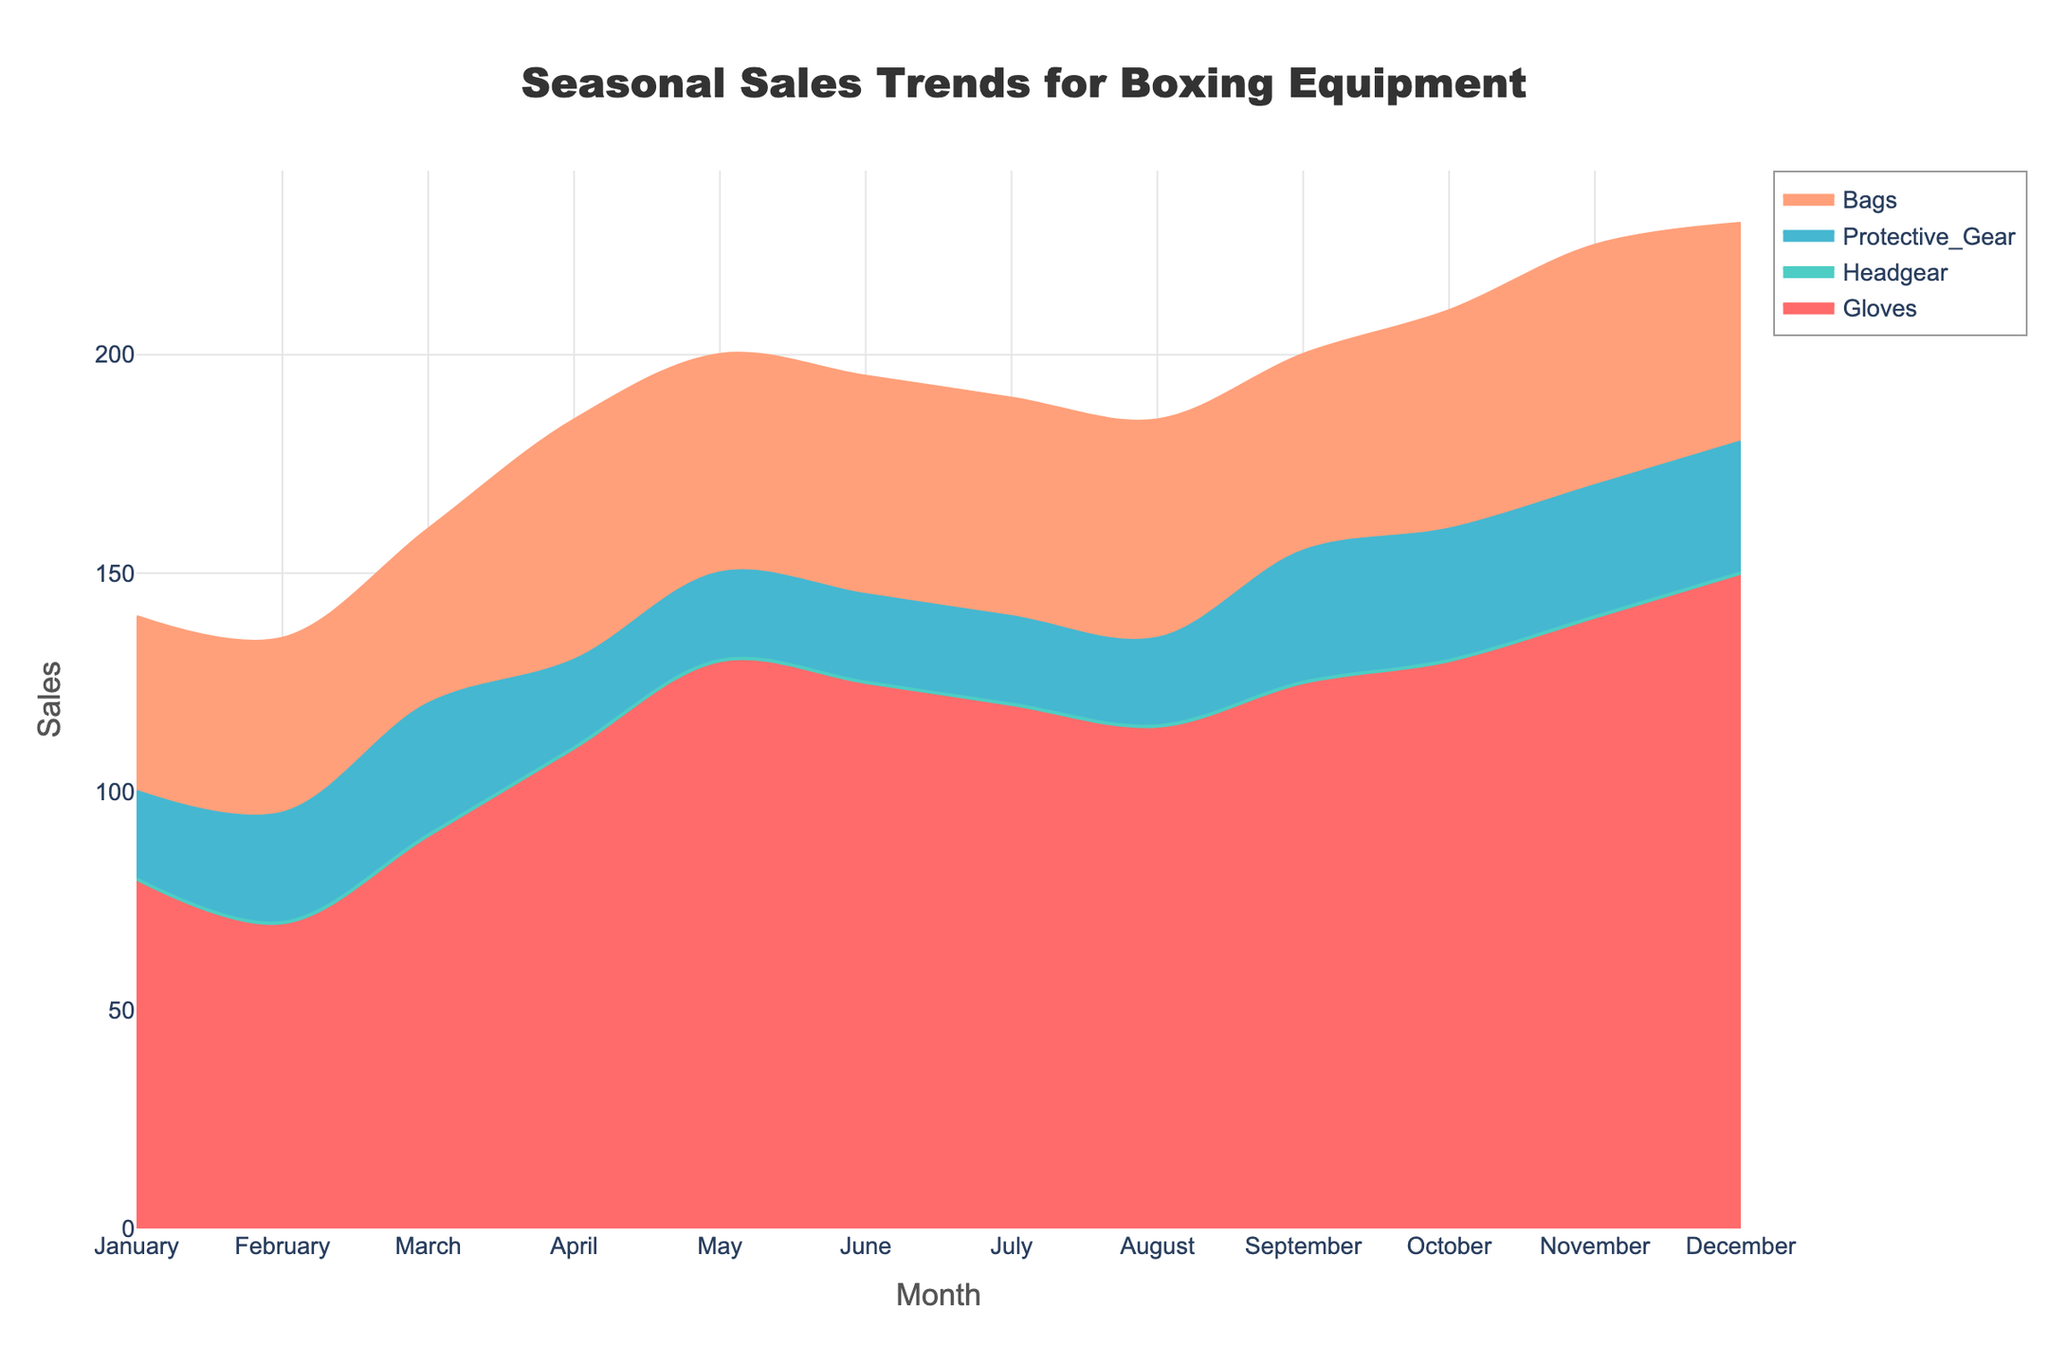What is the title of the plot? The title is located at the top of the figure. It describes the subject of the chart.
Answer: Seasonal Sales Trends for Boxing Equipment Which month has the highest sales for Gloves? To find the month with the highest sales for Gloves, we examine the 'Gloves' area on the chart and identify the peak value over the x-axis (months).
Answer: December What is the total sales for Protective Gear in the first quarter (January to March)? Sum the sales values for January, February, and March for Protective Gear: 100 + 95 + 120 = 315.
Answer: 315 How does the sales trend for Bags change from June to August? Examine the area representing Bags from June to August, noting the rise or fall in value over these months. Sales trend for Bags decreases from 195 in June to 190 in July and further to 185 in August.
Answer: Decreases Which category had the most consistent sales throughout the year? To determine which category had consistent sales, compare the fluctuations in the areas of the figure across all months. The 'Gloves' category shows the most consistent trends with fewer fluctuations.
Answer: Gloves What noticeable changes in sales occur between October and November? By comparing the peaks or area sizes between these two months for all categories, observe any significant trends or shifts. All categories show an increase, with Headgear sales rising from 130 to 140 and Protective Gear sales from 160 to 170.
Answer: Sales increase in all categories Which two months have equal sales for Gloves and Headgear? Look at both 'Gloves' and 'Headgear' areas and compare their sales values to find a common pair of months where numbers match.
Answer: None What is the average monthly sale of Bags for the year? Sum the sales values for each month and divide by 12 (total months): (140 + 135 + 160 + 185 + 200 + 195 + 190 + 185 + 200 + 210 + 225 + 230) / 12 = 188.75.
Answer: 188.75 How do sales of Gloves in January compare to December? Compare the height of the area representing Gloves in January and December on the y-axis to determine the difference. Sales for Gloves in December (200) are significantly higher than in January (120).
Answer: Higher in December 